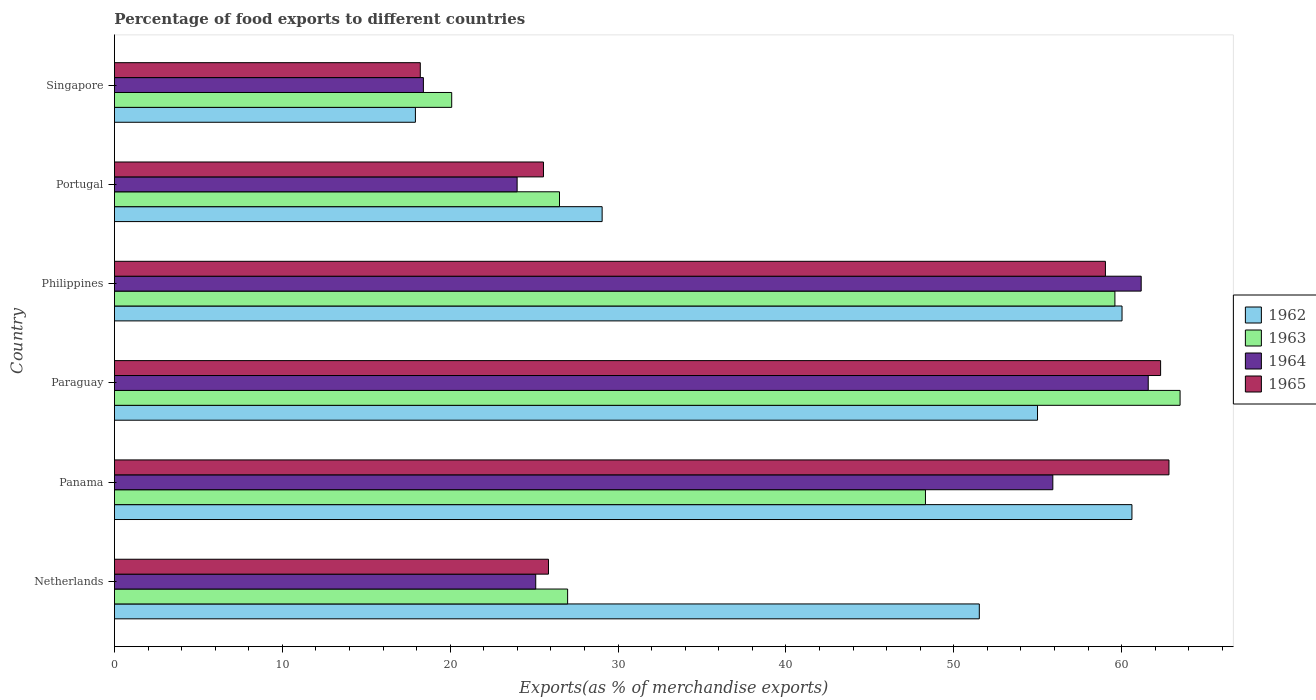How many different coloured bars are there?
Ensure brevity in your answer.  4. Are the number of bars per tick equal to the number of legend labels?
Keep it short and to the point. Yes. Are the number of bars on each tick of the Y-axis equal?
Your response must be concise. Yes. How many bars are there on the 1st tick from the top?
Provide a succinct answer. 4. How many bars are there on the 1st tick from the bottom?
Provide a succinct answer. 4. What is the label of the 3rd group of bars from the top?
Make the answer very short. Philippines. In how many cases, is the number of bars for a given country not equal to the number of legend labels?
Provide a succinct answer. 0. What is the percentage of exports to different countries in 1964 in Paraguay?
Make the answer very short. 61.59. Across all countries, what is the maximum percentage of exports to different countries in 1962?
Provide a succinct answer. 60.62. Across all countries, what is the minimum percentage of exports to different countries in 1964?
Your answer should be compact. 18.41. In which country was the percentage of exports to different countries in 1964 maximum?
Make the answer very short. Paraguay. In which country was the percentage of exports to different countries in 1965 minimum?
Your response must be concise. Singapore. What is the total percentage of exports to different countries in 1965 in the graph?
Your answer should be compact. 253.82. What is the difference between the percentage of exports to different countries in 1965 in Paraguay and that in Portugal?
Offer a terse response. 36.77. What is the difference between the percentage of exports to different countries in 1962 in Singapore and the percentage of exports to different countries in 1963 in Philippines?
Make the answer very short. -41.67. What is the average percentage of exports to different countries in 1964 per country?
Provide a short and direct response. 41.03. What is the difference between the percentage of exports to different countries in 1963 and percentage of exports to different countries in 1962 in Netherlands?
Provide a short and direct response. -24.53. What is the ratio of the percentage of exports to different countries in 1962 in Panama to that in Paraguay?
Your answer should be compact. 1.1. Is the percentage of exports to different countries in 1965 in Netherlands less than that in Philippines?
Offer a very short reply. Yes. Is the difference between the percentage of exports to different countries in 1963 in Netherlands and Philippines greater than the difference between the percentage of exports to different countries in 1962 in Netherlands and Philippines?
Make the answer very short. No. What is the difference between the highest and the second highest percentage of exports to different countries in 1962?
Offer a terse response. 0.59. What is the difference between the highest and the lowest percentage of exports to different countries in 1963?
Your response must be concise. 43.39. In how many countries, is the percentage of exports to different countries in 1965 greater than the average percentage of exports to different countries in 1965 taken over all countries?
Give a very brief answer. 3. Is the sum of the percentage of exports to different countries in 1963 in Netherlands and Singapore greater than the maximum percentage of exports to different countries in 1964 across all countries?
Offer a very short reply. No. Is it the case that in every country, the sum of the percentage of exports to different countries in 1963 and percentage of exports to different countries in 1964 is greater than the sum of percentage of exports to different countries in 1965 and percentage of exports to different countries in 1962?
Your response must be concise. No. What does the 2nd bar from the top in Portugal represents?
Provide a short and direct response. 1964. What does the 3rd bar from the bottom in Singapore represents?
Your answer should be compact. 1964. How many bars are there?
Offer a terse response. 24. How many countries are there in the graph?
Make the answer very short. 6. Does the graph contain grids?
Offer a very short reply. No. Where does the legend appear in the graph?
Your response must be concise. Center right. How many legend labels are there?
Your answer should be compact. 4. What is the title of the graph?
Provide a succinct answer. Percentage of food exports to different countries. Does "1995" appear as one of the legend labels in the graph?
Offer a terse response. No. What is the label or title of the X-axis?
Give a very brief answer. Exports(as % of merchandise exports). What is the Exports(as % of merchandise exports) of 1962 in Netherlands?
Ensure brevity in your answer.  51.52. What is the Exports(as % of merchandise exports) in 1963 in Netherlands?
Offer a terse response. 27. What is the Exports(as % of merchandise exports) of 1964 in Netherlands?
Your response must be concise. 25.1. What is the Exports(as % of merchandise exports) in 1965 in Netherlands?
Your answer should be compact. 25.86. What is the Exports(as % of merchandise exports) of 1962 in Panama?
Your response must be concise. 60.62. What is the Exports(as % of merchandise exports) in 1963 in Panama?
Your answer should be compact. 48.32. What is the Exports(as % of merchandise exports) of 1964 in Panama?
Give a very brief answer. 55.9. What is the Exports(as % of merchandise exports) of 1965 in Panama?
Ensure brevity in your answer.  62.82. What is the Exports(as % of merchandise exports) in 1962 in Paraguay?
Provide a short and direct response. 54.99. What is the Exports(as % of merchandise exports) of 1963 in Paraguay?
Ensure brevity in your answer.  63.48. What is the Exports(as % of merchandise exports) of 1964 in Paraguay?
Provide a succinct answer. 61.59. What is the Exports(as % of merchandise exports) in 1965 in Paraguay?
Make the answer very short. 62.32. What is the Exports(as % of merchandise exports) of 1962 in Philippines?
Offer a terse response. 60.03. What is the Exports(as % of merchandise exports) of 1963 in Philippines?
Provide a succinct answer. 59.6. What is the Exports(as % of merchandise exports) in 1964 in Philippines?
Keep it short and to the point. 61.17. What is the Exports(as % of merchandise exports) in 1965 in Philippines?
Provide a succinct answer. 59.04. What is the Exports(as % of merchandise exports) in 1962 in Portugal?
Your answer should be very brief. 29.05. What is the Exports(as % of merchandise exports) in 1963 in Portugal?
Ensure brevity in your answer.  26.51. What is the Exports(as % of merchandise exports) in 1964 in Portugal?
Offer a terse response. 23.99. What is the Exports(as % of merchandise exports) of 1965 in Portugal?
Offer a terse response. 25.56. What is the Exports(as % of merchandise exports) in 1962 in Singapore?
Provide a short and direct response. 17.93. What is the Exports(as % of merchandise exports) of 1963 in Singapore?
Make the answer very short. 20.09. What is the Exports(as % of merchandise exports) of 1964 in Singapore?
Provide a succinct answer. 18.41. What is the Exports(as % of merchandise exports) of 1965 in Singapore?
Your answer should be very brief. 18.22. Across all countries, what is the maximum Exports(as % of merchandise exports) of 1962?
Offer a terse response. 60.62. Across all countries, what is the maximum Exports(as % of merchandise exports) in 1963?
Your response must be concise. 63.48. Across all countries, what is the maximum Exports(as % of merchandise exports) in 1964?
Give a very brief answer. 61.59. Across all countries, what is the maximum Exports(as % of merchandise exports) in 1965?
Provide a succinct answer. 62.82. Across all countries, what is the minimum Exports(as % of merchandise exports) in 1962?
Offer a very short reply. 17.93. Across all countries, what is the minimum Exports(as % of merchandise exports) in 1963?
Keep it short and to the point. 20.09. Across all countries, what is the minimum Exports(as % of merchandise exports) in 1964?
Your response must be concise. 18.41. Across all countries, what is the minimum Exports(as % of merchandise exports) of 1965?
Your answer should be compact. 18.22. What is the total Exports(as % of merchandise exports) of 1962 in the graph?
Provide a succinct answer. 274.14. What is the total Exports(as % of merchandise exports) of 1963 in the graph?
Provide a short and direct response. 245.01. What is the total Exports(as % of merchandise exports) of 1964 in the graph?
Give a very brief answer. 246.15. What is the total Exports(as % of merchandise exports) of 1965 in the graph?
Provide a succinct answer. 253.82. What is the difference between the Exports(as % of merchandise exports) of 1962 in Netherlands and that in Panama?
Your response must be concise. -9.09. What is the difference between the Exports(as % of merchandise exports) in 1963 in Netherlands and that in Panama?
Offer a terse response. -21.32. What is the difference between the Exports(as % of merchandise exports) of 1964 in Netherlands and that in Panama?
Give a very brief answer. -30.81. What is the difference between the Exports(as % of merchandise exports) of 1965 in Netherlands and that in Panama?
Make the answer very short. -36.96. What is the difference between the Exports(as % of merchandise exports) of 1962 in Netherlands and that in Paraguay?
Your answer should be very brief. -3.47. What is the difference between the Exports(as % of merchandise exports) in 1963 in Netherlands and that in Paraguay?
Make the answer very short. -36.49. What is the difference between the Exports(as % of merchandise exports) in 1964 in Netherlands and that in Paraguay?
Offer a very short reply. -36.49. What is the difference between the Exports(as % of merchandise exports) of 1965 in Netherlands and that in Paraguay?
Ensure brevity in your answer.  -36.47. What is the difference between the Exports(as % of merchandise exports) in 1962 in Netherlands and that in Philippines?
Offer a terse response. -8.5. What is the difference between the Exports(as % of merchandise exports) in 1963 in Netherlands and that in Philippines?
Keep it short and to the point. -32.6. What is the difference between the Exports(as % of merchandise exports) in 1964 in Netherlands and that in Philippines?
Provide a short and direct response. -36.07. What is the difference between the Exports(as % of merchandise exports) of 1965 in Netherlands and that in Philippines?
Your answer should be very brief. -33.18. What is the difference between the Exports(as % of merchandise exports) of 1962 in Netherlands and that in Portugal?
Your answer should be compact. 22.47. What is the difference between the Exports(as % of merchandise exports) of 1963 in Netherlands and that in Portugal?
Keep it short and to the point. 0.48. What is the difference between the Exports(as % of merchandise exports) in 1964 in Netherlands and that in Portugal?
Give a very brief answer. 1.11. What is the difference between the Exports(as % of merchandise exports) of 1965 in Netherlands and that in Portugal?
Provide a short and direct response. 0.3. What is the difference between the Exports(as % of merchandise exports) of 1962 in Netherlands and that in Singapore?
Your response must be concise. 33.59. What is the difference between the Exports(as % of merchandise exports) in 1963 in Netherlands and that in Singapore?
Your response must be concise. 6.91. What is the difference between the Exports(as % of merchandise exports) in 1964 in Netherlands and that in Singapore?
Give a very brief answer. 6.69. What is the difference between the Exports(as % of merchandise exports) in 1965 in Netherlands and that in Singapore?
Provide a short and direct response. 7.64. What is the difference between the Exports(as % of merchandise exports) of 1962 in Panama and that in Paraguay?
Your answer should be compact. 5.62. What is the difference between the Exports(as % of merchandise exports) in 1963 in Panama and that in Paraguay?
Offer a terse response. -15.17. What is the difference between the Exports(as % of merchandise exports) in 1964 in Panama and that in Paraguay?
Ensure brevity in your answer.  -5.68. What is the difference between the Exports(as % of merchandise exports) in 1965 in Panama and that in Paraguay?
Provide a short and direct response. 0.5. What is the difference between the Exports(as % of merchandise exports) of 1962 in Panama and that in Philippines?
Offer a very short reply. 0.59. What is the difference between the Exports(as % of merchandise exports) in 1963 in Panama and that in Philippines?
Provide a succinct answer. -11.29. What is the difference between the Exports(as % of merchandise exports) in 1964 in Panama and that in Philippines?
Give a very brief answer. -5.26. What is the difference between the Exports(as % of merchandise exports) of 1965 in Panama and that in Philippines?
Your answer should be very brief. 3.79. What is the difference between the Exports(as % of merchandise exports) of 1962 in Panama and that in Portugal?
Keep it short and to the point. 31.56. What is the difference between the Exports(as % of merchandise exports) of 1963 in Panama and that in Portugal?
Make the answer very short. 21.8. What is the difference between the Exports(as % of merchandise exports) in 1964 in Panama and that in Portugal?
Your response must be concise. 31.91. What is the difference between the Exports(as % of merchandise exports) in 1965 in Panama and that in Portugal?
Keep it short and to the point. 37.26. What is the difference between the Exports(as % of merchandise exports) in 1962 in Panama and that in Singapore?
Offer a very short reply. 42.69. What is the difference between the Exports(as % of merchandise exports) in 1963 in Panama and that in Singapore?
Offer a terse response. 28.22. What is the difference between the Exports(as % of merchandise exports) of 1964 in Panama and that in Singapore?
Keep it short and to the point. 37.5. What is the difference between the Exports(as % of merchandise exports) of 1965 in Panama and that in Singapore?
Keep it short and to the point. 44.6. What is the difference between the Exports(as % of merchandise exports) of 1962 in Paraguay and that in Philippines?
Your answer should be compact. -5.03. What is the difference between the Exports(as % of merchandise exports) in 1963 in Paraguay and that in Philippines?
Your response must be concise. 3.88. What is the difference between the Exports(as % of merchandise exports) in 1964 in Paraguay and that in Philippines?
Offer a terse response. 0.42. What is the difference between the Exports(as % of merchandise exports) of 1965 in Paraguay and that in Philippines?
Provide a succinct answer. 3.29. What is the difference between the Exports(as % of merchandise exports) in 1962 in Paraguay and that in Portugal?
Your answer should be compact. 25.94. What is the difference between the Exports(as % of merchandise exports) in 1963 in Paraguay and that in Portugal?
Provide a succinct answer. 36.97. What is the difference between the Exports(as % of merchandise exports) in 1964 in Paraguay and that in Portugal?
Give a very brief answer. 37.6. What is the difference between the Exports(as % of merchandise exports) of 1965 in Paraguay and that in Portugal?
Your answer should be very brief. 36.77. What is the difference between the Exports(as % of merchandise exports) in 1962 in Paraguay and that in Singapore?
Offer a terse response. 37.06. What is the difference between the Exports(as % of merchandise exports) of 1963 in Paraguay and that in Singapore?
Ensure brevity in your answer.  43.39. What is the difference between the Exports(as % of merchandise exports) of 1964 in Paraguay and that in Singapore?
Provide a short and direct response. 43.18. What is the difference between the Exports(as % of merchandise exports) of 1965 in Paraguay and that in Singapore?
Your response must be concise. 44.1. What is the difference between the Exports(as % of merchandise exports) of 1962 in Philippines and that in Portugal?
Give a very brief answer. 30.97. What is the difference between the Exports(as % of merchandise exports) of 1963 in Philippines and that in Portugal?
Offer a terse response. 33.09. What is the difference between the Exports(as % of merchandise exports) of 1964 in Philippines and that in Portugal?
Provide a succinct answer. 37.18. What is the difference between the Exports(as % of merchandise exports) in 1965 in Philippines and that in Portugal?
Offer a very short reply. 33.48. What is the difference between the Exports(as % of merchandise exports) in 1962 in Philippines and that in Singapore?
Give a very brief answer. 42.1. What is the difference between the Exports(as % of merchandise exports) of 1963 in Philippines and that in Singapore?
Provide a succinct answer. 39.51. What is the difference between the Exports(as % of merchandise exports) of 1964 in Philippines and that in Singapore?
Provide a short and direct response. 42.76. What is the difference between the Exports(as % of merchandise exports) in 1965 in Philippines and that in Singapore?
Offer a terse response. 40.81. What is the difference between the Exports(as % of merchandise exports) of 1962 in Portugal and that in Singapore?
Your response must be concise. 11.12. What is the difference between the Exports(as % of merchandise exports) of 1963 in Portugal and that in Singapore?
Keep it short and to the point. 6.42. What is the difference between the Exports(as % of merchandise exports) of 1964 in Portugal and that in Singapore?
Provide a succinct answer. 5.58. What is the difference between the Exports(as % of merchandise exports) in 1965 in Portugal and that in Singapore?
Provide a short and direct response. 7.34. What is the difference between the Exports(as % of merchandise exports) of 1962 in Netherlands and the Exports(as % of merchandise exports) of 1963 in Panama?
Your answer should be very brief. 3.21. What is the difference between the Exports(as % of merchandise exports) in 1962 in Netherlands and the Exports(as % of merchandise exports) in 1964 in Panama?
Offer a terse response. -4.38. What is the difference between the Exports(as % of merchandise exports) in 1962 in Netherlands and the Exports(as % of merchandise exports) in 1965 in Panama?
Offer a terse response. -11.3. What is the difference between the Exports(as % of merchandise exports) of 1963 in Netherlands and the Exports(as % of merchandise exports) of 1964 in Panama?
Your response must be concise. -28.91. What is the difference between the Exports(as % of merchandise exports) in 1963 in Netherlands and the Exports(as % of merchandise exports) in 1965 in Panama?
Make the answer very short. -35.82. What is the difference between the Exports(as % of merchandise exports) of 1964 in Netherlands and the Exports(as % of merchandise exports) of 1965 in Panama?
Offer a terse response. -37.72. What is the difference between the Exports(as % of merchandise exports) in 1962 in Netherlands and the Exports(as % of merchandise exports) in 1963 in Paraguay?
Your answer should be compact. -11.96. What is the difference between the Exports(as % of merchandise exports) in 1962 in Netherlands and the Exports(as % of merchandise exports) in 1964 in Paraguay?
Provide a succinct answer. -10.06. What is the difference between the Exports(as % of merchandise exports) of 1962 in Netherlands and the Exports(as % of merchandise exports) of 1965 in Paraguay?
Ensure brevity in your answer.  -10.8. What is the difference between the Exports(as % of merchandise exports) of 1963 in Netherlands and the Exports(as % of merchandise exports) of 1964 in Paraguay?
Ensure brevity in your answer.  -34.59. What is the difference between the Exports(as % of merchandise exports) of 1963 in Netherlands and the Exports(as % of merchandise exports) of 1965 in Paraguay?
Ensure brevity in your answer.  -35.33. What is the difference between the Exports(as % of merchandise exports) of 1964 in Netherlands and the Exports(as % of merchandise exports) of 1965 in Paraguay?
Your answer should be very brief. -37.23. What is the difference between the Exports(as % of merchandise exports) in 1962 in Netherlands and the Exports(as % of merchandise exports) in 1963 in Philippines?
Your answer should be compact. -8.08. What is the difference between the Exports(as % of merchandise exports) of 1962 in Netherlands and the Exports(as % of merchandise exports) of 1964 in Philippines?
Ensure brevity in your answer.  -9.64. What is the difference between the Exports(as % of merchandise exports) in 1962 in Netherlands and the Exports(as % of merchandise exports) in 1965 in Philippines?
Offer a terse response. -7.51. What is the difference between the Exports(as % of merchandise exports) in 1963 in Netherlands and the Exports(as % of merchandise exports) in 1964 in Philippines?
Make the answer very short. -34.17. What is the difference between the Exports(as % of merchandise exports) of 1963 in Netherlands and the Exports(as % of merchandise exports) of 1965 in Philippines?
Your response must be concise. -32.04. What is the difference between the Exports(as % of merchandise exports) in 1964 in Netherlands and the Exports(as % of merchandise exports) in 1965 in Philippines?
Your answer should be compact. -33.94. What is the difference between the Exports(as % of merchandise exports) of 1962 in Netherlands and the Exports(as % of merchandise exports) of 1963 in Portugal?
Provide a succinct answer. 25.01. What is the difference between the Exports(as % of merchandise exports) of 1962 in Netherlands and the Exports(as % of merchandise exports) of 1964 in Portugal?
Ensure brevity in your answer.  27.53. What is the difference between the Exports(as % of merchandise exports) in 1962 in Netherlands and the Exports(as % of merchandise exports) in 1965 in Portugal?
Ensure brevity in your answer.  25.96. What is the difference between the Exports(as % of merchandise exports) in 1963 in Netherlands and the Exports(as % of merchandise exports) in 1964 in Portugal?
Provide a short and direct response. 3.01. What is the difference between the Exports(as % of merchandise exports) of 1963 in Netherlands and the Exports(as % of merchandise exports) of 1965 in Portugal?
Give a very brief answer. 1.44. What is the difference between the Exports(as % of merchandise exports) in 1964 in Netherlands and the Exports(as % of merchandise exports) in 1965 in Portugal?
Keep it short and to the point. -0.46. What is the difference between the Exports(as % of merchandise exports) of 1962 in Netherlands and the Exports(as % of merchandise exports) of 1963 in Singapore?
Provide a short and direct response. 31.43. What is the difference between the Exports(as % of merchandise exports) in 1962 in Netherlands and the Exports(as % of merchandise exports) in 1964 in Singapore?
Offer a terse response. 33.12. What is the difference between the Exports(as % of merchandise exports) in 1962 in Netherlands and the Exports(as % of merchandise exports) in 1965 in Singapore?
Offer a very short reply. 33.3. What is the difference between the Exports(as % of merchandise exports) in 1963 in Netherlands and the Exports(as % of merchandise exports) in 1964 in Singapore?
Offer a very short reply. 8.59. What is the difference between the Exports(as % of merchandise exports) of 1963 in Netherlands and the Exports(as % of merchandise exports) of 1965 in Singapore?
Give a very brief answer. 8.78. What is the difference between the Exports(as % of merchandise exports) in 1964 in Netherlands and the Exports(as % of merchandise exports) in 1965 in Singapore?
Provide a succinct answer. 6.88. What is the difference between the Exports(as % of merchandise exports) in 1962 in Panama and the Exports(as % of merchandise exports) in 1963 in Paraguay?
Offer a very short reply. -2.87. What is the difference between the Exports(as % of merchandise exports) of 1962 in Panama and the Exports(as % of merchandise exports) of 1964 in Paraguay?
Offer a terse response. -0.97. What is the difference between the Exports(as % of merchandise exports) of 1962 in Panama and the Exports(as % of merchandise exports) of 1965 in Paraguay?
Ensure brevity in your answer.  -1.71. What is the difference between the Exports(as % of merchandise exports) in 1963 in Panama and the Exports(as % of merchandise exports) in 1964 in Paraguay?
Your answer should be very brief. -13.27. What is the difference between the Exports(as % of merchandise exports) in 1963 in Panama and the Exports(as % of merchandise exports) in 1965 in Paraguay?
Give a very brief answer. -14.01. What is the difference between the Exports(as % of merchandise exports) of 1964 in Panama and the Exports(as % of merchandise exports) of 1965 in Paraguay?
Offer a terse response. -6.42. What is the difference between the Exports(as % of merchandise exports) of 1962 in Panama and the Exports(as % of merchandise exports) of 1963 in Philippines?
Give a very brief answer. 1.01. What is the difference between the Exports(as % of merchandise exports) of 1962 in Panama and the Exports(as % of merchandise exports) of 1964 in Philippines?
Your answer should be compact. -0.55. What is the difference between the Exports(as % of merchandise exports) of 1962 in Panama and the Exports(as % of merchandise exports) of 1965 in Philippines?
Ensure brevity in your answer.  1.58. What is the difference between the Exports(as % of merchandise exports) in 1963 in Panama and the Exports(as % of merchandise exports) in 1964 in Philippines?
Give a very brief answer. -12.85. What is the difference between the Exports(as % of merchandise exports) of 1963 in Panama and the Exports(as % of merchandise exports) of 1965 in Philippines?
Offer a very short reply. -10.72. What is the difference between the Exports(as % of merchandise exports) in 1964 in Panama and the Exports(as % of merchandise exports) in 1965 in Philippines?
Give a very brief answer. -3.13. What is the difference between the Exports(as % of merchandise exports) of 1962 in Panama and the Exports(as % of merchandise exports) of 1963 in Portugal?
Keep it short and to the point. 34.1. What is the difference between the Exports(as % of merchandise exports) in 1962 in Panama and the Exports(as % of merchandise exports) in 1964 in Portugal?
Your answer should be very brief. 36.63. What is the difference between the Exports(as % of merchandise exports) of 1962 in Panama and the Exports(as % of merchandise exports) of 1965 in Portugal?
Offer a terse response. 35.06. What is the difference between the Exports(as % of merchandise exports) in 1963 in Panama and the Exports(as % of merchandise exports) in 1964 in Portugal?
Ensure brevity in your answer.  24.33. What is the difference between the Exports(as % of merchandise exports) of 1963 in Panama and the Exports(as % of merchandise exports) of 1965 in Portugal?
Your response must be concise. 22.76. What is the difference between the Exports(as % of merchandise exports) of 1964 in Panama and the Exports(as % of merchandise exports) of 1965 in Portugal?
Keep it short and to the point. 30.34. What is the difference between the Exports(as % of merchandise exports) of 1962 in Panama and the Exports(as % of merchandise exports) of 1963 in Singapore?
Give a very brief answer. 40.52. What is the difference between the Exports(as % of merchandise exports) in 1962 in Panama and the Exports(as % of merchandise exports) in 1964 in Singapore?
Provide a short and direct response. 42.21. What is the difference between the Exports(as % of merchandise exports) of 1962 in Panama and the Exports(as % of merchandise exports) of 1965 in Singapore?
Provide a succinct answer. 42.39. What is the difference between the Exports(as % of merchandise exports) in 1963 in Panama and the Exports(as % of merchandise exports) in 1964 in Singapore?
Keep it short and to the point. 29.91. What is the difference between the Exports(as % of merchandise exports) of 1963 in Panama and the Exports(as % of merchandise exports) of 1965 in Singapore?
Provide a short and direct response. 30.09. What is the difference between the Exports(as % of merchandise exports) of 1964 in Panama and the Exports(as % of merchandise exports) of 1965 in Singapore?
Make the answer very short. 37.68. What is the difference between the Exports(as % of merchandise exports) in 1962 in Paraguay and the Exports(as % of merchandise exports) in 1963 in Philippines?
Ensure brevity in your answer.  -4.61. What is the difference between the Exports(as % of merchandise exports) of 1962 in Paraguay and the Exports(as % of merchandise exports) of 1964 in Philippines?
Ensure brevity in your answer.  -6.18. What is the difference between the Exports(as % of merchandise exports) of 1962 in Paraguay and the Exports(as % of merchandise exports) of 1965 in Philippines?
Your answer should be compact. -4.04. What is the difference between the Exports(as % of merchandise exports) in 1963 in Paraguay and the Exports(as % of merchandise exports) in 1964 in Philippines?
Give a very brief answer. 2.32. What is the difference between the Exports(as % of merchandise exports) of 1963 in Paraguay and the Exports(as % of merchandise exports) of 1965 in Philippines?
Keep it short and to the point. 4.45. What is the difference between the Exports(as % of merchandise exports) of 1964 in Paraguay and the Exports(as % of merchandise exports) of 1965 in Philippines?
Offer a very short reply. 2.55. What is the difference between the Exports(as % of merchandise exports) of 1962 in Paraguay and the Exports(as % of merchandise exports) of 1963 in Portugal?
Provide a succinct answer. 28.48. What is the difference between the Exports(as % of merchandise exports) in 1962 in Paraguay and the Exports(as % of merchandise exports) in 1964 in Portugal?
Your response must be concise. 31. What is the difference between the Exports(as % of merchandise exports) of 1962 in Paraguay and the Exports(as % of merchandise exports) of 1965 in Portugal?
Make the answer very short. 29.43. What is the difference between the Exports(as % of merchandise exports) of 1963 in Paraguay and the Exports(as % of merchandise exports) of 1964 in Portugal?
Your answer should be compact. 39.49. What is the difference between the Exports(as % of merchandise exports) in 1963 in Paraguay and the Exports(as % of merchandise exports) in 1965 in Portugal?
Your answer should be compact. 37.93. What is the difference between the Exports(as % of merchandise exports) in 1964 in Paraguay and the Exports(as % of merchandise exports) in 1965 in Portugal?
Your response must be concise. 36.03. What is the difference between the Exports(as % of merchandise exports) of 1962 in Paraguay and the Exports(as % of merchandise exports) of 1963 in Singapore?
Provide a short and direct response. 34.9. What is the difference between the Exports(as % of merchandise exports) in 1962 in Paraguay and the Exports(as % of merchandise exports) in 1964 in Singapore?
Your response must be concise. 36.59. What is the difference between the Exports(as % of merchandise exports) in 1962 in Paraguay and the Exports(as % of merchandise exports) in 1965 in Singapore?
Offer a very short reply. 36.77. What is the difference between the Exports(as % of merchandise exports) of 1963 in Paraguay and the Exports(as % of merchandise exports) of 1964 in Singapore?
Keep it short and to the point. 45.08. What is the difference between the Exports(as % of merchandise exports) of 1963 in Paraguay and the Exports(as % of merchandise exports) of 1965 in Singapore?
Offer a terse response. 45.26. What is the difference between the Exports(as % of merchandise exports) in 1964 in Paraguay and the Exports(as % of merchandise exports) in 1965 in Singapore?
Give a very brief answer. 43.37. What is the difference between the Exports(as % of merchandise exports) in 1962 in Philippines and the Exports(as % of merchandise exports) in 1963 in Portugal?
Provide a short and direct response. 33.51. What is the difference between the Exports(as % of merchandise exports) in 1962 in Philippines and the Exports(as % of merchandise exports) in 1964 in Portugal?
Make the answer very short. 36.04. What is the difference between the Exports(as % of merchandise exports) in 1962 in Philippines and the Exports(as % of merchandise exports) in 1965 in Portugal?
Your response must be concise. 34.47. What is the difference between the Exports(as % of merchandise exports) in 1963 in Philippines and the Exports(as % of merchandise exports) in 1964 in Portugal?
Offer a terse response. 35.61. What is the difference between the Exports(as % of merchandise exports) of 1963 in Philippines and the Exports(as % of merchandise exports) of 1965 in Portugal?
Provide a succinct answer. 34.04. What is the difference between the Exports(as % of merchandise exports) of 1964 in Philippines and the Exports(as % of merchandise exports) of 1965 in Portugal?
Make the answer very short. 35.61. What is the difference between the Exports(as % of merchandise exports) of 1962 in Philippines and the Exports(as % of merchandise exports) of 1963 in Singapore?
Give a very brief answer. 39.93. What is the difference between the Exports(as % of merchandise exports) in 1962 in Philippines and the Exports(as % of merchandise exports) in 1964 in Singapore?
Ensure brevity in your answer.  41.62. What is the difference between the Exports(as % of merchandise exports) in 1962 in Philippines and the Exports(as % of merchandise exports) in 1965 in Singapore?
Give a very brief answer. 41.8. What is the difference between the Exports(as % of merchandise exports) in 1963 in Philippines and the Exports(as % of merchandise exports) in 1964 in Singapore?
Your answer should be very brief. 41.2. What is the difference between the Exports(as % of merchandise exports) in 1963 in Philippines and the Exports(as % of merchandise exports) in 1965 in Singapore?
Your answer should be compact. 41.38. What is the difference between the Exports(as % of merchandise exports) in 1964 in Philippines and the Exports(as % of merchandise exports) in 1965 in Singapore?
Provide a short and direct response. 42.95. What is the difference between the Exports(as % of merchandise exports) in 1962 in Portugal and the Exports(as % of merchandise exports) in 1963 in Singapore?
Offer a terse response. 8.96. What is the difference between the Exports(as % of merchandise exports) in 1962 in Portugal and the Exports(as % of merchandise exports) in 1964 in Singapore?
Keep it short and to the point. 10.65. What is the difference between the Exports(as % of merchandise exports) of 1962 in Portugal and the Exports(as % of merchandise exports) of 1965 in Singapore?
Offer a terse response. 10.83. What is the difference between the Exports(as % of merchandise exports) of 1963 in Portugal and the Exports(as % of merchandise exports) of 1964 in Singapore?
Provide a succinct answer. 8.11. What is the difference between the Exports(as % of merchandise exports) of 1963 in Portugal and the Exports(as % of merchandise exports) of 1965 in Singapore?
Your answer should be very brief. 8.29. What is the difference between the Exports(as % of merchandise exports) of 1964 in Portugal and the Exports(as % of merchandise exports) of 1965 in Singapore?
Your response must be concise. 5.77. What is the average Exports(as % of merchandise exports) in 1962 per country?
Your answer should be very brief. 45.69. What is the average Exports(as % of merchandise exports) of 1963 per country?
Ensure brevity in your answer.  40.83. What is the average Exports(as % of merchandise exports) of 1964 per country?
Provide a short and direct response. 41.03. What is the average Exports(as % of merchandise exports) in 1965 per country?
Offer a terse response. 42.3. What is the difference between the Exports(as % of merchandise exports) in 1962 and Exports(as % of merchandise exports) in 1963 in Netherlands?
Offer a terse response. 24.53. What is the difference between the Exports(as % of merchandise exports) of 1962 and Exports(as % of merchandise exports) of 1964 in Netherlands?
Keep it short and to the point. 26.43. What is the difference between the Exports(as % of merchandise exports) of 1962 and Exports(as % of merchandise exports) of 1965 in Netherlands?
Ensure brevity in your answer.  25.67. What is the difference between the Exports(as % of merchandise exports) in 1963 and Exports(as % of merchandise exports) in 1964 in Netherlands?
Offer a terse response. 1.9. What is the difference between the Exports(as % of merchandise exports) of 1963 and Exports(as % of merchandise exports) of 1965 in Netherlands?
Your response must be concise. 1.14. What is the difference between the Exports(as % of merchandise exports) in 1964 and Exports(as % of merchandise exports) in 1965 in Netherlands?
Provide a short and direct response. -0.76. What is the difference between the Exports(as % of merchandise exports) in 1962 and Exports(as % of merchandise exports) in 1963 in Panama?
Your answer should be very brief. 12.3. What is the difference between the Exports(as % of merchandise exports) in 1962 and Exports(as % of merchandise exports) in 1964 in Panama?
Your response must be concise. 4.71. What is the difference between the Exports(as % of merchandise exports) of 1962 and Exports(as % of merchandise exports) of 1965 in Panama?
Ensure brevity in your answer.  -2.21. What is the difference between the Exports(as % of merchandise exports) in 1963 and Exports(as % of merchandise exports) in 1964 in Panama?
Make the answer very short. -7.59. What is the difference between the Exports(as % of merchandise exports) of 1963 and Exports(as % of merchandise exports) of 1965 in Panama?
Give a very brief answer. -14.51. What is the difference between the Exports(as % of merchandise exports) of 1964 and Exports(as % of merchandise exports) of 1965 in Panama?
Make the answer very short. -6.92. What is the difference between the Exports(as % of merchandise exports) of 1962 and Exports(as % of merchandise exports) of 1963 in Paraguay?
Ensure brevity in your answer.  -8.49. What is the difference between the Exports(as % of merchandise exports) of 1962 and Exports(as % of merchandise exports) of 1964 in Paraguay?
Offer a terse response. -6.6. What is the difference between the Exports(as % of merchandise exports) of 1962 and Exports(as % of merchandise exports) of 1965 in Paraguay?
Make the answer very short. -7.33. What is the difference between the Exports(as % of merchandise exports) of 1963 and Exports(as % of merchandise exports) of 1964 in Paraguay?
Offer a terse response. 1.9. What is the difference between the Exports(as % of merchandise exports) in 1963 and Exports(as % of merchandise exports) in 1965 in Paraguay?
Your response must be concise. 1.16. What is the difference between the Exports(as % of merchandise exports) in 1964 and Exports(as % of merchandise exports) in 1965 in Paraguay?
Make the answer very short. -0.74. What is the difference between the Exports(as % of merchandise exports) of 1962 and Exports(as % of merchandise exports) of 1963 in Philippines?
Provide a short and direct response. 0.42. What is the difference between the Exports(as % of merchandise exports) of 1962 and Exports(as % of merchandise exports) of 1964 in Philippines?
Provide a short and direct response. -1.14. What is the difference between the Exports(as % of merchandise exports) of 1963 and Exports(as % of merchandise exports) of 1964 in Philippines?
Your answer should be very brief. -1.57. What is the difference between the Exports(as % of merchandise exports) in 1963 and Exports(as % of merchandise exports) in 1965 in Philippines?
Your answer should be very brief. 0.57. What is the difference between the Exports(as % of merchandise exports) of 1964 and Exports(as % of merchandise exports) of 1965 in Philippines?
Offer a very short reply. 2.13. What is the difference between the Exports(as % of merchandise exports) in 1962 and Exports(as % of merchandise exports) in 1963 in Portugal?
Give a very brief answer. 2.54. What is the difference between the Exports(as % of merchandise exports) in 1962 and Exports(as % of merchandise exports) in 1964 in Portugal?
Provide a succinct answer. 5.06. What is the difference between the Exports(as % of merchandise exports) of 1962 and Exports(as % of merchandise exports) of 1965 in Portugal?
Keep it short and to the point. 3.49. What is the difference between the Exports(as % of merchandise exports) of 1963 and Exports(as % of merchandise exports) of 1964 in Portugal?
Offer a very short reply. 2.52. What is the difference between the Exports(as % of merchandise exports) of 1963 and Exports(as % of merchandise exports) of 1965 in Portugal?
Your response must be concise. 0.95. What is the difference between the Exports(as % of merchandise exports) of 1964 and Exports(as % of merchandise exports) of 1965 in Portugal?
Offer a very short reply. -1.57. What is the difference between the Exports(as % of merchandise exports) of 1962 and Exports(as % of merchandise exports) of 1963 in Singapore?
Offer a very short reply. -2.16. What is the difference between the Exports(as % of merchandise exports) in 1962 and Exports(as % of merchandise exports) in 1964 in Singapore?
Your answer should be very brief. -0.48. What is the difference between the Exports(as % of merchandise exports) of 1962 and Exports(as % of merchandise exports) of 1965 in Singapore?
Offer a very short reply. -0.29. What is the difference between the Exports(as % of merchandise exports) in 1963 and Exports(as % of merchandise exports) in 1964 in Singapore?
Your answer should be very brief. 1.69. What is the difference between the Exports(as % of merchandise exports) in 1963 and Exports(as % of merchandise exports) in 1965 in Singapore?
Make the answer very short. 1.87. What is the difference between the Exports(as % of merchandise exports) in 1964 and Exports(as % of merchandise exports) in 1965 in Singapore?
Your response must be concise. 0.18. What is the ratio of the Exports(as % of merchandise exports) in 1963 in Netherlands to that in Panama?
Give a very brief answer. 0.56. What is the ratio of the Exports(as % of merchandise exports) in 1964 in Netherlands to that in Panama?
Your response must be concise. 0.45. What is the ratio of the Exports(as % of merchandise exports) in 1965 in Netherlands to that in Panama?
Your answer should be compact. 0.41. What is the ratio of the Exports(as % of merchandise exports) of 1962 in Netherlands to that in Paraguay?
Provide a succinct answer. 0.94. What is the ratio of the Exports(as % of merchandise exports) of 1963 in Netherlands to that in Paraguay?
Provide a succinct answer. 0.43. What is the ratio of the Exports(as % of merchandise exports) of 1964 in Netherlands to that in Paraguay?
Give a very brief answer. 0.41. What is the ratio of the Exports(as % of merchandise exports) of 1965 in Netherlands to that in Paraguay?
Keep it short and to the point. 0.41. What is the ratio of the Exports(as % of merchandise exports) in 1962 in Netherlands to that in Philippines?
Provide a succinct answer. 0.86. What is the ratio of the Exports(as % of merchandise exports) in 1963 in Netherlands to that in Philippines?
Your answer should be compact. 0.45. What is the ratio of the Exports(as % of merchandise exports) of 1964 in Netherlands to that in Philippines?
Make the answer very short. 0.41. What is the ratio of the Exports(as % of merchandise exports) of 1965 in Netherlands to that in Philippines?
Your response must be concise. 0.44. What is the ratio of the Exports(as % of merchandise exports) in 1962 in Netherlands to that in Portugal?
Offer a very short reply. 1.77. What is the ratio of the Exports(as % of merchandise exports) of 1963 in Netherlands to that in Portugal?
Ensure brevity in your answer.  1.02. What is the ratio of the Exports(as % of merchandise exports) of 1964 in Netherlands to that in Portugal?
Provide a succinct answer. 1.05. What is the ratio of the Exports(as % of merchandise exports) of 1965 in Netherlands to that in Portugal?
Keep it short and to the point. 1.01. What is the ratio of the Exports(as % of merchandise exports) of 1962 in Netherlands to that in Singapore?
Your answer should be very brief. 2.87. What is the ratio of the Exports(as % of merchandise exports) of 1963 in Netherlands to that in Singapore?
Your answer should be compact. 1.34. What is the ratio of the Exports(as % of merchandise exports) of 1964 in Netherlands to that in Singapore?
Provide a short and direct response. 1.36. What is the ratio of the Exports(as % of merchandise exports) of 1965 in Netherlands to that in Singapore?
Make the answer very short. 1.42. What is the ratio of the Exports(as % of merchandise exports) of 1962 in Panama to that in Paraguay?
Your response must be concise. 1.1. What is the ratio of the Exports(as % of merchandise exports) of 1963 in Panama to that in Paraguay?
Your answer should be compact. 0.76. What is the ratio of the Exports(as % of merchandise exports) in 1964 in Panama to that in Paraguay?
Provide a succinct answer. 0.91. What is the ratio of the Exports(as % of merchandise exports) in 1962 in Panama to that in Philippines?
Ensure brevity in your answer.  1.01. What is the ratio of the Exports(as % of merchandise exports) in 1963 in Panama to that in Philippines?
Your response must be concise. 0.81. What is the ratio of the Exports(as % of merchandise exports) in 1964 in Panama to that in Philippines?
Provide a succinct answer. 0.91. What is the ratio of the Exports(as % of merchandise exports) of 1965 in Panama to that in Philippines?
Offer a very short reply. 1.06. What is the ratio of the Exports(as % of merchandise exports) in 1962 in Panama to that in Portugal?
Your answer should be compact. 2.09. What is the ratio of the Exports(as % of merchandise exports) in 1963 in Panama to that in Portugal?
Provide a succinct answer. 1.82. What is the ratio of the Exports(as % of merchandise exports) in 1964 in Panama to that in Portugal?
Give a very brief answer. 2.33. What is the ratio of the Exports(as % of merchandise exports) in 1965 in Panama to that in Portugal?
Your response must be concise. 2.46. What is the ratio of the Exports(as % of merchandise exports) of 1962 in Panama to that in Singapore?
Offer a terse response. 3.38. What is the ratio of the Exports(as % of merchandise exports) of 1963 in Panama to that in Singapore?
Your response must be concise. 2.4. What is the ratio of the Exports(as % of merchandise exports) in 1964 in Panama to that in Singapore?
Your answer should be compact. 3.04. What is the ratio of the Exports(as % of merchandise exports) in 1965 in Panama to that in Singapore?
Your answer should be compact. 3.45. What is the ratio of the Exports(as % of merchandise exports) in 1962 in Paraguay to that in Philippines?
Keep it short and to the point. 0.92. What is the ratio of the Exports(as % of merchandise exports) in 1963 in Paraguay to that in Philippines?
Give a very brief answer. 1.07. What is the ratio of the Exports(as % of merchandise exports) in 1965 in Paraguay to that in Philippines?
Give a very brief answer. 1.06. What is the ratio of the Exports(as % of merchandise exports) in 1962 in Paraguay to that in Portugal?
Provide a succinct answer. 1.89. What is the ratio of the Exports(as % of merchandise exports) of 1963 in Paraguay to that in Portugal?
Offer a very short reply. 2.39. What is the ratio of the Exports(as % of merchandise exports) in 1964 in Paraguay to that in Portugal?
Provide a succinct answer. 2.57. What is the ratio of the Exports(as % of merchandise exports) in 1965 in Paraguay to that in Portugal?
Keep it short and to the point. 2.44. What is the ratio of the Exports(as % of merchandise exports) in 1962 in Paraguay to that in Singapore?
Give a very brief answer. 3.07. What is the ratio of the Exports(as % of merchandise exports) of 1963 in Paraguay to that in Singapore?
Make the answer very short. 3.16. What is the ratio of the Exports(as % of merchandise exports) in 1964 in Paraguay to that in Singapore?
Offer a very short reply. 3.35. What is the ratio of the Exports(as % of merchandise exports) of 1965 in Paraguay to that in Singapore?
Give a very brief answer. 3.42. What is the ratio of the Exports(as % of merchandise exports) in 1962 in Philippines to that in Portugal?
Your answer should be very brief. 2.07. What is the ratio of the Exports(as % of merchandise exports) in 1963 in Philippines to that in Portugal?
Your answer should be very brief. 2.25. What is the ratio of the Exports(as % of merchandise exports) of 1964 in Philippines to that in Portugal?
Provide a succinct answer. 2.55. What is the ratio of the Exports(as % of merchandise exports) in 1965 in Philippines to that in Portugal?
Give a very brief answer. 2.31. What is the ratio of the Exports(as % of merchandise exports) in 1962 in Philippines to that in Singapore?
Ensure brevity in your answer.  3.35. What is the ratio of the Exports(as % of merchandise exports) in 1963 in Philippines to that in Singapore?
Make the answer very short. 2.97. What is the ratio of the Exports(as % of merchandise exports) of 1964 in Philippines to that in Singapore?
Ensure brevity in your answer.  3.32. What is the ratio of the Exports(as % of merchandise exports) of 1965 in Philippines to that in Singapore?
Offer a terse response. 3.24. What is the ratio of the Exports(as % of merchandise exports) in 1962 in Portugal to that in Singapore?
Offer a terse response. 1.62. What is the ratio of the Exports(as % of merchandise exports) of 1963 in Portugal to that in Singapore?
Offer a terse response. 1.32. What is the ratio of the Exports(as % of merchandise exports) in 1964 in Portugal to that in Singapore?
Keep it short and to the point. 1.3. What is the ratio of the Exports(as % of merchandise exports) in 1965 in Portugal to that in Singapore?
Your answer should be very brief. 1.4. What is the difference between the highest and the second highest Exports(as % of merchandise exports) in 1962?
Ensure brevity in your answer.  0.59. What is the difference between the highest and the second highest Exports(as % of merchandise exports) of 1963?
Your response must be concise. 3.88. What is the difference between the highest and the second highest Exports(as % of merchandise exports) of 1964?
Make the answer very short. 0.42. What is the difference between the highest and the second highest Exports(as % of merchandise exports) of 1965?
Your response must be concise. 0.5. What is the difference between the highest and the lowest Exports(as % of merchandise exports) in 1962?
Your answer should be very brief. 42.69. What is the difference between the highest and the lowest Exports(as % of merchandise exports) of 1963?
Ensure brevity in your answer.  43.39. What is the difference between the highest and the lowest Exports(as % of merchandise exports) of 1964?
Offer a terse response. 43.18. What is the difference between the highest and the lowest Exports(as % of merchandise exports) in 1965?
Your answer should be compact. 44.6. 